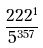Convert formula to latex. <formula><loc_0><loc_0><loc_500><loc_500>\frac { 2 2 2 ^ { 1 } } { 5 ^ { 3 5 7 } }</formula> 